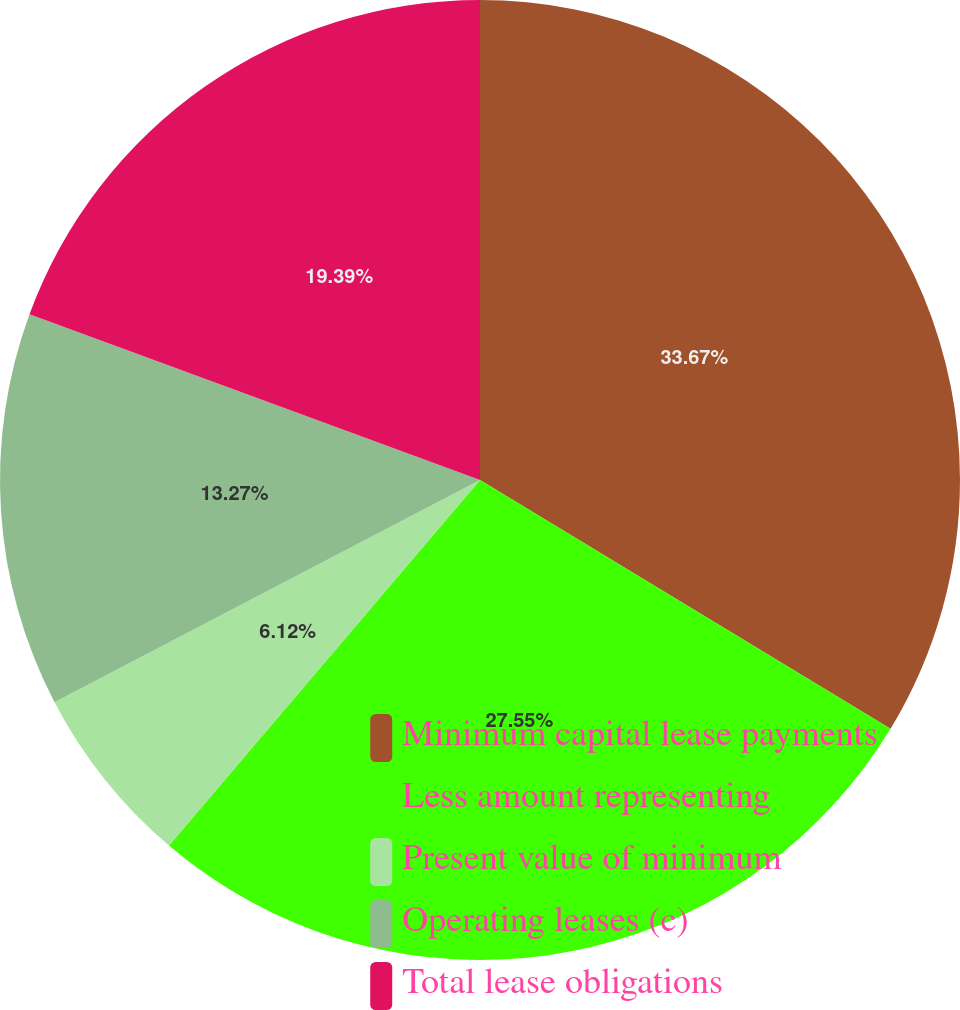Convert chart. <chart><loc_0><loc_0><loc_500><loc_500><pie_chart><fcel>Minimum capital lease payments<fcel>Less amount representing<fcel>Present value of minimum<fcel>Operating leases (c)<fcel>Total lease obligations<nl><fcel>33.67%<fcel>27.55%<fcel>6.12%<fcel>13.27%<fcel>19.39%<nl></chart> 